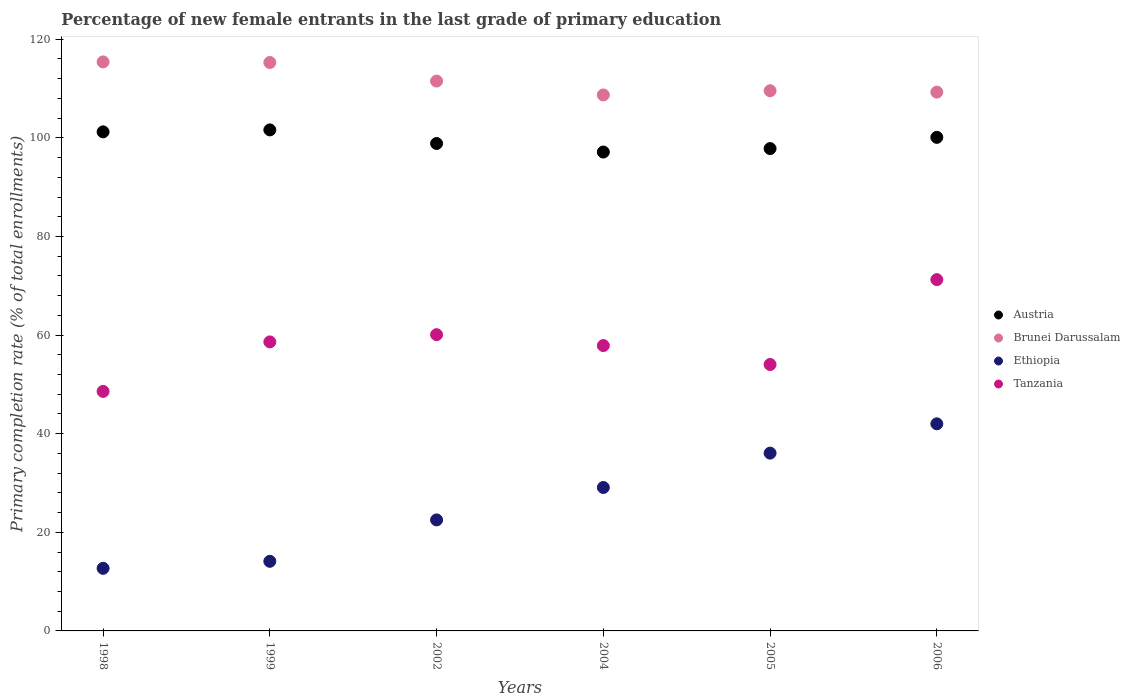Is the number of dotlines equal to the number of legend labels?
Give a very brief answer. Yes. What is the percentage of new female entrants in Ethiopia in 2005?
Offer a terse response. 36.06. Across all years, what is the maximum percentage of new female entrants in Ethiopia?
Ensure brevity in your answer.  42. Across all years, what is the minimum percentage of new female entrants in Austria?
Your response must be concise. 97.12. What is the total percentage of new female entrants in Ethiopia in the graph?
Your answer should be very brief. 156.48. What is the difference between the percentage of new female entrants in Ethiopia in 1998 and that in 2004?
Your answer should be very brief. -16.39. What is the difference between the percentage of new female entrants in Ethiopia in 2006 and the percentage of new female entrants in Brunei Darussalam in 2004?
Provide a succinct answer. -66.7. What is the average percentage of new female entrants in Austria per year?
Your answer should be compact. 99.45. In the year 1999, what is the difference between the percentage of new female entrants in Tanzania and percentage of new female entrants in Ethiopia?
Provide a succinct answer. 44.5. What is the ratio of the percentage of new female entrants in Ethiopia in 2002 to that in 2005?
Your answer should be compact. 0.62. Is the difference between the percentage of new female entrants in Tanzania in 2002 and 2004 greater than the difference between the percentage of new female entrants in Ethiopia in 2002 and 2004?
Offer a terse response. Yes. What is the difference between the highest and the second highest percentage of new female entrants in Brunei Darussalam?
Ensure brevity in your answer.  0.12. What is the difference between the highest and the lowest percentage of new female entrants in Brunei Darussalam?
Make the answer very short. 6.7. Is the sum of the percentage of new female entrants in Austria in 2002 and 2006 greater than the maximum percentage of new female entrants in Ethiopia across all years?
Provide a succinct answer. Yes. Is it the case that in every year, the sum of the percentage of new female entrants in Austria and percentage of new female entrants in Tanzania  is greater than the percentage of new female entrants in Brunei Darussalam?
Your answer should be compact. Yes. Does the percentage of new female entrants in Austria monotonically increase over the years?
Keep it short and to the point. No. Is the percentage of new female entrants in Austria strictly greater than the percentage of new female entrants in Brunei Darussalam over the years?
Your answer should be very brief. No. Is the percentage of new female entrants in Ethiopia strictly less than the percentage of new female entrants in Brunei Darussalam over the years?
Provide a short and direct response. Yes. What is the difference between two consecutive major ticks on the Y-axis?
Keep it short and to the point. 20. Are the values on the major ticks of Y-axis written in scientific E-notation?
Your answer should be very brief. No. Where does the legend appear in the graph?
Keep it short and to the point. Center right. What is the title of the graph?
Your response must be concise. Percentage of new female entrants in the last grade of primary education. What is the label or title of the X-axis?
Give a very brief answer. Years. What is the label or title of the Y-axis?
Offer a terse response. Primary completion rate (% of total enrollments). What is the Primary completion rate (% of total enrollments) in Austria in 1998?
Ensure brevity in your answer.  101.21. What is the Primary completion rate (% of total enrollments) in Brunei Darussalam in 1998?
Your answer should be very brief. 115.4. What is the Primary completion rate (% of total enrollments) in Ethiopia in 1998?
Offer a very short reply. 12.7. What is the Primary completion rate (% of total enrollments) in Tanzania in 1998?
Provide a short and direct response. 48.58. What is the Primary completion rate (% of total enrollments) in Austria in 1999?
Provide a short and direct response. 101.61. What is the Primary completion rate (% of total enrollments) of Brunei Darussalam in 1999?
Offer a terse response. 115.28. What is the Primary completion rate (% of total enrollments) in Ethiopia in 1999?
Your answer should be very brief. 14.12. What is the Primary completion rate (% of total enrollments) of Tanzania in 1999?
Make the answer very short. 58.62. What is the Primary completion rate (% of total enrollments) in Austria in 2002?
Give a very brief answer. 98.85. What is the Primary completion rate (% of total enrollments) of Brunei Darussalam in 2002?
Provide a short and direct response. 111.51. What is the Primary completion rate (% of total enrollments) of Ethiopia in 2002?
Offer a very short reply. 22.51. What is the Primary completion rate (% of total enrollments) of Tanzania in 2002?
Keep it short and to the point. 60.09. What is the Primary completion rate (% of total enrollments) in Austria in 2004?
Your response must be concise. 97.12. What is the Primary completion rate (% of total enrollments) of Brunei Darussalam in 2004?
Keep it short and to the point. 108.7. What is the Primary completion rate (% of total enrollments) in Ethiopia in 2004?
Offer a terse response. 29.09. What is the Primary completion rate (% of total enrollments) in Tanzania in 2004?
Your answer should be compact. 57.87. What is the Primary completion rate (% of total enrollments) of Austria in 2005?
Your answer should be very brief. 97.82. What is the Primary completion rate (% of total enrollments) of Brunei Darussalam in 2005?
Ensure brevity in your answer.  109.55. What is the Primary completion rate (% of total enrollments) in Ethiopia in 2005?
Offer a very short reply. 36.06. What is the Primary completion rate (% of total enrollments) in Tanzania in 2005?
Your answer should be very brief. 54.04. What is the Primary completion rate (% of total enrollments) in Austria in 2006?
Make the answer very short. 100.1. What is the Primary completion rate (% of total enrollments) of Brunei Darussalam in 2006?
Give a very brief answer. 109.27. What is the Primary completion rate (% of total enrollments) of Ethiopia in 2006?
Make the answer very short. 42. What is the Primary completion rate (% of total enrollments) in Tanzania in 2006?
Your answer should be compact. 71.25. Across all years, what is the maximum Primary completion rate (% of total enrollments) of Austria?
Keep it short and to the point. 101.61. Across all years, what is the maximum Primary completion rate (% of total enrollments) in Brunei Darussalam?
Provide a short and direct response. 115.4. Across all years, what is the maximum Primary completion rate (% of total enrollments) of Ethiopia?
Give a very brief answer. 42. Across all years, what is the maximum Primary completion rate (% of total enrollments) of Tanzania?
Your answer should be very brief. 71.25. Across all years, what is the minimum Primary completion rate (% of total enrollments) of Austria?
Make the answer very short. 97.12. Across all years, what is the minimum Primary completion rate (% of total enrollments) in Brunei Darussalam?
Provide a succinct answer. 108.7. Across all years, what is the minimum Primary completion rate (% of total enrollments) in Ethiopia?
Provide a succinct answer. 12.7. Across all years, what is the minimum Primary completion rate (% of total enrollments) in Tanzania?
Your answer should be very brief. 48.58. What is the total Primary completion rate (% of total enrollments) of Austria in the graph?
Give a very brief answer. 596.72. What is the total Primary completion rate (% of total enrollments) of Brunei Darussalam in the graph?
Offer a terse response. 669.72. What is the total Primary completion rate (% of total enrollments) in Ethiopia in the graph?
Offer a terse response. 156.48. What is the total Primary completion rate (% of total enrollments) in Tanzania in the graph?
Make the answer very short. 350.43. What is the difference between the Primary completion rate (% of total enrollments) of Austria in 1998 and that in 1999?
Your response must be concise. -0.4. What is the difference between the Primary completion rate (% of total enrollments) of Brunei Darussalam in 1998 and that in 1999?
Your answer should be compact. 0.12. What is the difference between the Primary completion rate (% of total enrollments) in Ethiopia in 1998 and that in 1999?
Provide a succinct answer. -1.42. What is the difference between the Primary completion rate (% of total enrollments) of Tanzania in 1998 and that in 1999?
Your answer should be compact. -10.04. What is the difference between the Primary completion rate (% of total enrollments) in Austria in 1998 and that in 2002?
Make the answer very short. 2.36. What is the difference between the Primary completion rate (% of total enrollments) of Brunei Darussalam in 1998 and that in 2002?
Give a very brief answer. 3.89. What is the difference between the Primary completion rate (% of total enrollments) of Ethiopia in 1998 and that in 2002?
Keep it short and to the point. -9.82. What is the difference between the Primary completion rate (% of total enrollments) of Tanzania in 1998 and that in 2002?
Make the answer very short. -11.51. What is the difference between the Primary completion rate (% of total enrollments) of Austria in 1998 and that in 2004?
Keep it short and to the point. 4.09. What is the difference between the Primary completion rate (% of total enrollments) in Brunei Darussalam in 1998 and that in 2004?
Your answer should be very brief. 6.7. What is the difference between the Primary completion rate (% of total enrollments) in Ethiopia in 1998 and that in 2004?
Offer a very short reply. -16.39. What is the difference between the Primary completion rate (% of total enrollments) of Tanzania in 1998 and that in 2004?
Your response must be concise. -9.29. What is the difference between the Primary completion rate (% of total enrollments) of Austria in 1998 and that in 2005?
Your answer should be compact. 3.39. What is the difference between the Primary completion rate (% of total enrollments) of Brunei Darussalam in 1998 and that in 2005?
Offer a terse response. 5.85. What is the difference between the Primary completion rate (% of total enrollments) of Ethiopia in 1998 and that in 2005?
Keep it short and to the point. -23.36. What is the difference between the Primary completion rate (% of total enrollments) of Tanzania in 1998 and that in 2005?
Keep it short and to the point. -5.46. What is the difference between the Primary completion rate (% of total enrollments) of Austria in 1998 and that in 2006?
Give a very brief answer. 1.11. What is the difference between the Primary completion rate (% of total enrollments) of Brunei Darussalam in 1998 and that in 2006?
Give a very brief answer. 6.13. What is the difference between the Primary completion rate (% of total enrollments) in Ethiopia in 1998 and that in 2006?
Keep it short and to the point. -29.3. What is the difference between the Primary completion rate (% of total enrollments) of Tanzania in 1998 and that in 2006?
Make the answer very short. -22.67. What is the difference between the Primary completion rate (% of total enrollments) in Austria in 1999 and that in 2002?
Ensure brevity in your answer.  2.76. What is the difference between the Primary completion rate (% of total enrollments) in Brunei Darussalam in 1999 and that in 2002?
Keep it short and to the point. 3.77. What is the difference between the Primary completion rate (% of total enrollments) of Ethiopia in 1999 and that in 2002?
Offer a very short reply. -8.4. What is the difference between the Primary completion rate (% of total enrollments) in Tanzania in 1999 and that in 2002?
Your answer should be very brief. -1.47. What is the difference between the Primary completion rate (% of total enrollments) of Austria in 1999 and that in 2004?
Ensure brevity in your answer.  4.49. What is the difference between the Primary completion rate (% of total enrollments) of Brunei Darussalam in 1999 and that in 2004?
Provide a short and direct response. 6.58. What is the difference between the Primary completion rate (% of total enrollments) in Ethiopia in 1999 and that in 2004?
Your response must be concise. -14.97. What is the difference between the Primary completion rate (% of total enrollments) in Tanzania in 1999 and that in 2004?
Keep it short and to the point. 0.75. What is the difference between the Primary completion rate (% of total enrollments) in Austria in 1999 and that in 2005?
Provide a succinct answer. 3.79. What is the difference between the Primary completion rate (% of total enrollments) of Brunei Darussalam in 1999 and that in 2005?
Keep it short and to the point. 5.73. What is the difference between the Primary completion rate (% of total enrollments) in Ethiopia in 1999 and that in 2005?
Offer a very short reply. -21.94. What is the difference between the Primary completion rate (% of total enrollments) in Tanzania in 1999 and that in 2005?
Your response must be concise. 4.58. What is the difference between the Primary completion rate (% of total enrollments) in Austria in 1999 and that in 2006?
Give a very brief answer. 1.51. What is the difference between the Primary completion rate (% of total enrollments) in Brunei Darussalam in 1999 and that in 2006?
Your answer should be very brief. 6.01. What is the difference between the Primary completion rate (% of total enrollments) of Ethiopia in 1999 and that in 2006?
Provide a succinct answer. -27.88. What is the difference between the Primary completion rate (% of total enrollments) in Tanzania in 1999 and that in 2006?
Provide a short and direct response. -12.63. What is the difference between the Primary completion rate (% of total enrollments) in Austria in 2002 and that in 2004?
Your answer should be very brief. 1.73. What is the difference between the Primary completion rate (% of total enrollments) of Brunei Darussalam in 2002 and that in 2004?
Your response must be concise. 2.81. What is the difference between the Primary completion rate (% of total enrollments) of Ethiopia in 2002 and that in 2004?
Your answer should be very brief. -6.58. What is the difference between the Primary completion rate (% of total enrollments) of Tanzania in 2002 and that in 2004?
Give a very brief answer. 2.22. What is the difference between the Primary completion rate (% of total enrollments) in Austria in 2002 and that in 2005?
Keep it short and to the point. 1.03. What is the difference between the Primary completion rate (% of total enrollments) in Brunei Darussalam in 2002 and that in 2005?
Your answer should be very brief. 1.96. What is the difference between the Primary completion rate (% of total enrollments) of Ethiopia in 2002 and that in 2005?
Your response must be concise. -13.54. What is the difference between the Primary completion rate (% of total enrollments) in Tanzania in 2002 and that in 2005?
Make the answer very short. 6.05. What is the difference between the Primary completion rate (% of total enrollments) in Austria in 2002 and that in 2006?
Offer a terse response. -1.25. What is the difference between the Primary completion rate (% of total enrollments) in Brunei Darussalam in 2002 and that in 2006?
Offer a very short reply. 2.24. What is the difference between the Primary completion rate (% of total enrollments) of Ethiopia in 2002 and that in 2006?
Your answer should be compact. -19.49. What is the difference between the Primary completion rate (% of total enrollments) in Tanzania in 2002 and that in 2006?
Your answer should be compact. -11.16. What is the difference between the Primary completion rate (% of total enrollments) in Austria in 2004 and that in 2005?
Your answer should be compact. -0.7. What is the difference between the Primary completion rate (% of total enrollments) in Brunei Darussalam in 2004 and that in 2005?
Provide a succinct answer. -0.85. What is the difference between the Primary completion rate (% of total enrollments) of Ethiopia in 2004 and that in 2005?
Give a very brief answer. -6.97. What is the difference between the Primary completion rate (% of total enrollments) of Tanzania in 2004 and that in 2005?
Provide a succinct answer. 3.83. What is the difference between the Primary completion rate (% of total enrollments) of Austria in 2004 and that in 2006?
Ensure brevity in your answer.  -2.98. What is the difference between the Primary completion rate (% of total enrollments) in Brunei Darussalam in 2004 and that in 2006?
Make the answer very short. -0.58. What is the difference between the Primary completion rate (% of total enrollments) of Ethiopia in 2004 and that in 2006?
Give a very brief answer. -12.91. What is the difference between the Primary completion rate (% of total enrollments) in Tanzania in 2004 and that in 2006?
Your response must be concise. -13.38. What is the difference between the Primary completion rate (% of total enrollments) in Austria in 2005 and that in 2006?
Your answer should be compact. -2.28. What is the difference between the Primary completion rate (% of total enrollments) in Brunei Darussalam in 2005 and that in 2006?
Give a very brief answer. 0.28. What is the difference between the Primary completion rate (% of total enrollments) of Ethiopia in 2005 and that in 2006?
Ensure brevity in your answer.  -5.94. What is the difference between the Primary completion rate (% of total enrollments) of Tanzania in 2005 and that in 2006?
Offer a very short reply. -17.21. What is the difference between the Primary completion rate (% of total enrollments) of Austria in 1998 and the Primary completion rate (% of total enrollments) of Brunei Darussalam in 1999?
Keep it short and to the point. -14.07. What is the difference between the Primary completion rate (% of total enrollments) in Austria in 1998 and the Primary completion rate (% of total enrollments) in Ethiopia in 1999?
Ensure brevity in your answer.  87.1. What is the difference between the Primary completion rate (% of total enrollments) in Austria in 1998 and the Primary completion rate (% of total enrollments) in Tanzania in 1999?
Your answer should be compact. 42.6. What is the difference between the Primary completion rate (% of total enrollments) of Brunei Darussalam in 1998 and the Primary completion rate (% of total enrollments) of Ethiopia in 1999?
Provide a short and direct response. 101.29. What is the difference between the Primary completion rate (% of total enrollments) of Brunei Darussalam in 1998 and the Primary completion rate (% of total enrollments) of Tanzania in 1999?
Your answer should be compact. 56.79. What is the difference between the Primary completion rate (% of total enrollments) in Ethiopia in 1998 and the Primary completion rate (% of total enrollments) in Tanzania in 1999?
Provide a succinct answer. -45.92. What is the difference between the Primary completion rate (% of total enrollments) of Austria in 1998 and the Primary completion rate (% of total enrollments) of Brunei Darussalam in 2002?
Offer a very short reply. -10.3. What is the difference between the Primary completion rate (% of total enrollments) of Austria in 1998 and the Primary completion rate (% of total enrollments) of Ethiopia in 2002?
Ensure brevity in your answer.  78.7. What is the difference between the Primary completion rate (% of total enrollments) of Austria in 1998 and the Primary completion rate (% of total enrollments) of Tanzania in 2002?
Give a very brief answer. 41.13. What is the difference between the Primary completion rate (% of total enrollments) in Brunei Darussalam in 1998 and the Primary completion rate (% of total enrollments) in Ethiopia in 2002?
Provide a short and direct response. 92.89. What is the difference between the Primary completion rate (% of total enrollments) of Brunei Darussalam in 1998 and the Primary completion rate (% of total enrollments) of Tanzania in 2002?
Offer a terse response. 55.32. What is the difference between the Primary completion rate (% of total enrollments) of Ethiopia in 1998 and the Primary completion rate (% of total enrollments) of Tanzania in 2002?
Make the answer very short. -47.39. What is the difference between the Primary completion rate (% of total enrollments) of Austria in 1998 and the Primary completion rate (% of total enrollments) of Brunei Darussalam in 2004?
Ensure brevity in your answer.  -7.48. What is the difference between the Primary completion rate (% of total enrollments) in Austria in 1998 and the Primary completion rate (% of total enrollments) in Ethiopia in 2004?
Your answer should be compact. 72.12. What is the difference between the Primary completion rate (% of total enrollments) in Austria in 1998 and the Primary completion rate (% of total enrollments) in Tanzania in 2004?
Provide a succinct answer. 43.35. What is the difference between the Primary completion rate (% of total enrollments) in Brunei Darussalam in 1998 and the Primary completion rate (% of total enrollments) in Ethiopia in 2004?
Your answer should be compact. 86.31. What is the difference between the Primary completion rate (% of total enrollments) of Brunei Darussalam in 1998 and the Primary completion rate (% of total enrollments) of Tanzania in 2004?
Offer a very short reply. 57.53. What is the difference between the Primary completion rate (% of total enrollments) of Ethiopia in 1998 and the Primary completion rate (% of total enrollments) of Tanzania in 2004?
Keep it short and to the point. -45.17. What is the difference between the Primary completion rate (% of total enrollments) in Austria in 1998 and the Primary completion rate (% of total enrollments) in Brunei Darussalam in 2005?
Give a very brief answer. -8.34. What is the difference between the Primary completion rate (% of total enrollments) in Austria in 1998 and the Primary completion rate (% of total enrollments) in Ethiopia in 2005?
Provide a short and direct response. 65.16. What is the difference between the Primary completion rate (% of total enrollments) in Austria in 1998 and the Primary completion rate (% of total enrollments) in Tanzania in 2005?
Provide a succinct answer. 47.18. What is the difference between the Primary completion rate (% of total enrollments) in Brunei Darussalam in 1998 and the Primary completion rate (% of total enrollments) in Ethiopia in 2005?
Your answer should be very brief. 79.34. What is the difference between the Primary completion rate (% of total enrollments) in Brunei Darussalam in 1998 and the Primary completion rate (% of total enrollments) in Tanzania in 2005?
Ensure brevity in your answer.  61.37. What is the difference between the Primary completion rate (% of total enrollments) of Ethiopia in 1998 and the Primary completion rate (% of total enrollments) of Tanzania in 2005?
Your answer should be compact. -41.34. What is the difference between the Primary completion rate (% of total enrollments) of Austria in 1998 and the Primary completion rate (% of total enrollments) of Brunei Darussalam in 2006?
Make the answer very short. -8.06. What is the difference between the Primary completion rate (% of total enrollments) of Austria in 1998 and the Primary completion rate (% of total enrollments) of Ethiopia in 2006?
Give a very brief answer. 59.21. What is the difference between the Primary completion rate (% of total enrollments) in Austria in 1998 and the Primary completion rate (% of total enrollments) in Tanzania in 2006?
Make the answer very short. 29.97. What is the difference between the Primary completion rate (% of total enrollments) of Brunei Darussalam in 1998 and the Primary completion rate (% of total enrollments) of Ethiopia in 2006?
Ensure brevity in your answer.  73.4. What is the difference between the Primary completion rate (% of total enrollments) of Brunei Darussalam in 1998 and the Primary completion rate (% of total enrollments) of Tanzania in 2006?
Provide a short and direct response. 44.16. What is the difference between the Primary completion rate (% of total enrollments) of Ethiopia in 1998 and the Primary completion rate (% of total enrollments) of Tanzania in 2006?
Your response must be concise. -58.55. What is the difference between the Primary completion rate (% of total enrollments) of Austria in 1999 and the Primary completion rate (% of total enrollments) of Brunei Darussalam in 2002?
Your answer should be very brief. -9.9. What is the difference between the Primary completion rate (% of total enrollments) in Austria in 1999 and the Primary completion rate (% of total enrollments) in Ethiopia in 2002?
Keep it short and to the point. 79.1. What is the difference between the Primary completion rate (% of total enrollments) in Austria in 1999 and the Primary completion rate (% of total enrollments) in Tanzania in 2002?
Make the answer very short. 41.53. What is the difference between the Primary completion rate (% of total enrollments) in Brunei Darussalam in 1999 and the Primary completion rate (% of total enrollments) in Ethiopia in 2002?
Provide a succinct answer. 92.77. What is the difference between the Primary completion rate (% of total enrollments) in Brunei Darussalam in 1999 and the Primary completion rate (% of total enrollments) in Tanzania in 2002?
Give a very brief answer. 55.2. What is the difference between the Primary completion rate (% of total enrollments) of Ethiopia in 1999 and the Primary completion rate (% of total enrollments) of Tanzania in 2002?
Your answer should be compact. -45.97. What is the difference between the Primary completion rate (% of total enrollments) in Austria in 1999 and the Primary completion rate (% of total enrollments) in Brunei Darussalam in 2004?
Make the answer very short. -7.09. What is the difference between the Primary completion rate (% of total enrollments) of Austria in 1999 and the Primary completion rate (% of total enrollments) of Ethiopia in 2004?
Make the answer very short. 72.52. What is the difference between the Primary completion rate (% of total enrollments) of Austria in 1999 and the Primary completion rate (% of total enrollments) of Tanzania in 2004?
Provide a short and direct response. 43.74. What is the difference between the Primary completion rate (% of total enrollments) of Brunei Darussalam in 1999 and the Primary completion rate (% of total enrollments) of Ethiopia in 2004?
Ensure brevity in your answer.  86.19. What is the difference between the Primary completion rate (% of total enrollments) in Brunei Darussalam in 1999 and the Primary completion rate (% of total enrollments) in Tanzania in 2004?
Your response must be concise. 57.41. What is the difference between the Primary completion rate (% of total enrollments) in Ethiopia in 1999 and the Primary completion rate (% of total enrollments) in Tanzania in 2004?
Offer a terse response. -43.75. What is the difference between the Primary completion rate (% of total enrollments) in Austria in 1999 and the Primary completion rate (% of total enrollments) in Brunei Darussalam in 2005?
Give a very brief answer. -7.94. What is the difference between the Primary completion rate (% of total enrollments) in Austria in 1999 and the Primary completion rate (% of total enrollments) in Ethiopia in 2005?
Your answer should be very brief. 65.55. What is the difference between the Primary completion rate (% of total enrollments) of Austria in 1999 and the Primary completion rate (% of total enrollments) of Tanzania in 2005?
Provide a succinct answer. 47.57. What is the difference between the Primary completion rate (% of total enrollments) in Brunei Darussalam in 1999 and the Primary completion rate (% of total enrollments) in Ethiopia in 2005?
Your answer should be very brief. 79.22. What is the difference between the Primary completion rate (% of total enrollments) of Brunei Darussalam in 1999 and the Primary completion rate (% of total enrollments) of Tanzania in 2005?
Provide a short and direct response. 61.24. What is the difference between the Primary completion rate (% of total enrollments) of Ethiopia in 1999 and the Primary completion rate (% of total enrollments) of Tanzania in 2005?
Give a very brief answer. -39.92. What is the difference between the Primary completion rate (% of total enrollments) of Austria in 1999 and the Primary completion rate (% of total enrollments) of Brunei Darussalam in 2006?
Provide a succinct answer. -7.66. What is the difference between the Primary completion rate (% of total enrollments) of Austria in 1999 and the Primary completion rate (% of total enrollments) of Ethiopia in 2006?
Give a very brief answer. 59.61. What is the difference between the Primary completion rate (% of total enrollments) in Austria in 1999 and the Primary completion rate (% of total enrollments) in Tanzania in 2006?
Your answer should be very brief. 30.37. What is the difference between the Primary completion rate (% of total enrollments) of Brunei Darussalam in 1999 and the Primary completion rate (% of total enrollments) of Ethiopia in 2006?
Your answer should be very brief. 73.28. What is the difference between the Primary completion rate (% of total enrollments) of Brunei Darussalam in 1999 and the Primary completion rate (% of total enrollments) of Tanzania in 2006?
Offer a very short reply. 44.03. What is the difference between the Primary completion rate (% of total enrollments) of Ethiopia in 1999 and the Primary completion rate (% of total enrollments) of Tanzania in 2006?
Your answer should be compact. -57.13. What is the difference between the Primary completion rate (% of total enrollments) of Austria in 2002 and the Primary completion rate (% of total enrollments) of Brunei Darussalam in 2004?
Keep it short and to the point. -9.84. What is the difference between the Primary completion rate (% of total enrollments) in Austria in 2002 and the Primary completion rate (% of total enrollments) in Ethiopia in 2004?
Ensure brevity in your answer.  69.76. What is the difference between the Primary completion rate (% of total enrollments) in Austria in 2002 and the Primary completion rate (% of total enrollments) in Tanzania in 2004?
Offer a very short reply. 40.99. What is the difference between the Primary completion rate (% of total enrollments) in Brunei Darussalam in 2002 and the Primary completion rate (% of total enrollments) in Ethiopia in 2004?
Your answer should be very brief. 82.42. What is the difference between the Primary completion rate (% of total enrollments) of Brunei Darussalam in 2002 and the Primary completion rate (% of total enrollments) of Tanzania in 2004?
Provide a succinct answer. 53.65. What is the difference between the Primary completion rate (% of total enrollments) in Ethiopia in 2002 and the Primary completion rate (% of total enrollments) in Tanzania in 2004?
Provide a succinct answer. -35.35. What is the difference between the Primary completion rate (% of total enrollments) of Austria in 2002 and the Primary completion rate (% of total enrollments) of Brunei Darussalam in 2005?
Provide a short and direct response. -10.7. What is the difference between the Primary completion rate (% of total enrollments) in Austria in 2002 and the Primary completion rate (% of total enrollments) in Ethiopia in 2005?
Make the answer very short. 62.8. What is the difference between the Primary completion rate (% of total enrollments) of Austria in 2002 and the Primary completion rate (% of total enrollments) of Tanzania in 2005?
Offer a terse response. 44.82. What is the difference between the Primary completion rate (% of total enrollments) of Brunei Darussalam in 2002 and the Primary completion rate (% of total enrollments) of Ethiopia in 2005?
Ensure brevity in your answer.  75.45. What is the difference between the Primary completion rate (% of total enrollments) in Brunei Darussalam in 2002 and the Primary completion rate (% of total enrollments) in Tanzania in 2005?
Provide a short and direct response. 57.48. What is the difference between the Primary completion rate (% of total enrollments) in Ethiopia in 2002 and the Primary completion rate (% of total enrollments) in Tanzania in 2005?
Your answer should be compact. -31.52. What is the difference between the Primary completion rate (% of total enrollments) of Austria in 2002 and the Primary completion rate (% of total enrollments) of Brunei Darussalam in 2006?
Give a very brief answer. -10.42. What is the difference between the Primary completion rate (% of total enrollments) of Austria in 2002 and the Primary completion rate (% of total enrollments) of Ethiopia in 2006?
Your answer should be compact. 56.85. What is the difference between the Primary completion rate (% of total enrollments) in Austria in 2002 and the Primary completion rate (% of total enrollments) in Tanzania in 2006?
Provide a succinct answer. 27.61. What is the difference between the Primary completion rate (% of total enrollments) of Brunei Darussalam in 2002 and the Primary completion rate (% of total enrollments) of Ethiopia in 2006?
Offer a terse response. 69.51. What is the difference between the Primary completion rate (% of total enrollments) in Brunei Darussalam in 2002 and the Primary completion rate (% of total enrollments) in Tanzania in 2006?
Offer a terse response. 40.27. What is the difference between the Primary completion rate (% of total enrollments) of Ethiopia in 2002 and the Primary completion rate (% of total enrollments) of Tanzania in 2006?
Your answer should be very brief. -48.73. What is the difference between the Primary completion rate (% of total enrollments) of Austria in 2004 and the Primary completion rate (% of total enrollments) of Brunei Darussalam in 2005?
Give a very brief answer. -12.43. What is the difference between the Primary completion rate (% of total enrollments) in Austria in 2004 and the Primary completion rate (% of total enrollments) in Ethiopia in 2005?
Ensure brevity in your answer.  61.06. What is the difference between the Primary completion rate (% of total enrollments) of Austria in 2004 and the Primary completion rate (% of total enrollments) of Tanzania in 2005?
Give a very brief answer. 43.08. What is the difference between the Primary completion rate (% of total enrollments) in Brunei Darussalam in 2004 and the Primary completion rate (% of total enrollments) in Ethiopia in 2005?
Offer a very short reply. 72.64. What is the difference between the Primary completion rate (% of total enrollments) in Brunei Darussalam in 2004 and the Primary completion rate (% of total enrollments) in Tanzania in 2005?
Keep it short and to the point. 54.66. What is the difference between the Primary completion rate (% of total enrollments) in Ethiopia in 2004 and the Primary completion rate (% of total enrollments) in Tanzania in 2005?
Your answer should be very brief. -24.95. What is the difference between the Primary completion rate (% of total enrollments) in Austria in 2004 and the Primary completion rate (% of total enrollments) in Brunei Darussalam in 2006?
Your response must be concise. -12.15. What is the difference between the Primary completion rate (% of total enrollments) in Austria in 2004 and the Primary completion rate (% of total enrollments) in Ethiopia in 2006?
Ensure brevity in your answer.  55.12. What is the difference between the Primary completion rate (% of total enrollments) of Austria in 2004 and the Primary completion rate (% of total enrollments) of Tanzania in 2006?
Your response must be concise. 25.88. What is the difference between the Primary completion rate (% of total enrollments) in Brunei Darussalam in 2004 and the Primary completion rate (% of total enrollments) in Ethiopia in 2006?
Provide a succinct answer. 66.7. What is the difference between the Primary completion rate (% of total enrollments) in Brunei Darussalam in 2004 and the Primary completion rate (% of total enrollments) in Tanzania in 2006?
Provide a succinct answer. 37.45. What is the difference between the Primary completion rate (% of total enrollments) of Ethiopia in 2004 and the Primary completion rate (% of total enrollments) of Tanzania in 2006?
Offer a terse response. -42.16. What is the difference between the Primary completion rate (% of total enrollments) of Austria in 2005 and the Primary completion rate (% of total enrollments) of Brunei Darussalam in 2006?
Your answer should be very brief. -11.45. What is the difference between the Primary completion rate (% of total enrollments) of Austria in 2005 and the Primary completion rate (% of total enrollments) of Ethiopia in 2006?
Keep it short and to the point. 55.82. What is the difference between the Primary completion rate (% of total enrollments) in Austria in 2005 and the Primary completion rate (% of total enrollments) in Tanzania in 2006?
Keep it short and to the point. 26.57. What is the difference between the Primary completion rate (% of total enrollments) of Brunei Darussalam in 2005 and the Primary completion rate (% of total enrollments) of Ethiopia in 2006?
Your response must be concise. 67.55. What is the difference between the Primary completion rate (% of total enrollments) in Brunei Darussalam in 2005 and the Primary completion rate (% of total enrollments) in Tanzania in 2006?
Make the answer very short. 38.31. What is the difference between the Primary completion rate (% of total enrollments) in Ethiopia in 2005 and the Primary completion rate (% of total enrollments) in Tanzania in 2006?
Offer a terse response. -35.19. What is the average Primary completion rate (% of total enrollments) in Austria per year?
Ensure brevity in your answer.  99.45. What is the average Primary completion rate (% of total enrollments) in Brunei Darussalam per year?
Offer a terse response. 111.62. What is the average Primary completion rate (% of total enrollments) of Ethiopia per year?
Keep it short and to the point. 26.08. What is the average Primary completion rate (% of total enrollments) in Tanzania per year?
Offer a terse response. 58.4. In the year 1998, what is the difference between the Primary completion rate (% of total enrollments) in Austria and Primary completion rate (% of total enrollments) in Brunei Darussalam?
Your answer should be compact. -14.19. In the year 1998, what is the difference between the Primary completion rate (% of total enrollments) in Austria and Primary completion rate (% of total enrollments) in Ethiopia?
Ensure brevity in your answer.  88.52. In the year 1998, what is the difference between the Primary completion rate (% of total enrollments) of Austria and Primary completion rate (% of total enrollments) of Tanzania?
Your answer should be very brief. 52.64. In the year 1998, what is the difference between the Primary completion rate (% of total enrollments) of Brunei Darussalam and Primary completion rate (% of total enrollments) of Ethiopia?
Offer a terse response. 102.71. In the year 1998, what is the difference between the Primary completion rate (% of total enrollments) in Brunei Darussalam and Primary completion rate (% of total enrollments) in Tanzania?
Your response must be concise. 66.83. In the year 1998, what is the difference between the Primary completion rate (% of total enrollments) of Ethiopia and Primary completion rate (% of total enrollments) of Tanzania?
Give a very brief answer. -35.88. In the year 1999, what is the difference between the Primary completion rate (% of total enrollments) in Austria and Primary completion rate (% of total enrollments) in Brunei Darussalam?
Your answer should be very brief. -13.67. In the year 1999, what is the difference between the Primary completion rate (% of total enrollments) in Austria and Primary completion rate (% of total enrollments) in Ethiopia?
Your answer should be compact. 87.49. In the year 1999, what is the difference between the Primary completion rate (% of total enrollments) in Austria and Primary completion rate (% of total enrollments) in Tanzania?
Give a very brief answer. 43. In the year 1999, what is the difference between the Primary completion rate (% of total enrollments) in Brunei Darussalam and Primary completion rate (% of total enrollments) in Ethiopia?
Offer a very short reply. 101.16. In the year 1999, what is the difference between the Primary completion rate (% of total enrollments) of Brunei Darussalam and Primary completion rate (% of total enrollments) of Tanzania?
Provide a short and direct response. 56.66. In the year 1999, what is the difference between the Primary completion rate (% of total enrollments) in Ethiopia and Primary completion rate (% of total enrollments) in Tanzania?
Ensure brevity in your answer.  -44.5. In the year 2002, what is the difference between the Primary completion rate (% of total enrollments) of Austria and Primary completion rate (% of total enrollments) of Brunei Darussalam?
Offer a very short reply. -12.66. In the year 2002, what is the difference between the Primary completion rate (% of total enrollments) in Austria and Primary completion rate (% of total enrollments) in Ethiopia?
Offer a very short reply. 76.34. In the year 2002, what is the difference between the Primary completion rate (% of total enrollments) in Austria and Primary completion rate (% of total enrollments) in Tanzania?
Keep it short and to the point. 38.77. In the year 2002, what is the difference between the Primary completion rate (% of total enrollments) of Brunei Darussalam and Primary completion rate (% of total enrollments) of Ethiopia?
Your answer should be compact. 89. In the year 2002, what is the difference between the Primary completion rate (% of total enrollments) in Brunei Darussalam and Primary completion rate (% of total enrollments) in Tanzania?
Offer a very short reply. 51.43. In the year 2002, what is the difference between the Primary completion rate (% of total enrollments) of Ethiopia and Primary completion rate (% of total enrollments) of Tanzania?
Provide a short and direct response. -37.57. In the year 2004, what is the difference between the Primary completion rate (% of total enrollments) in Austria and Primary completion rate (% of total enrollments) in Brunei Darussalam?
Make the answer very short. -11.58. In the year 2004, what is the difference between the Primary completion rate (% of total enrollments) of Austria and Primary completion rate (% of total enrollments) of Ethiopia?
Ensure brevity in your answer.  68.03. In the year 2004, what is the difference between the Primary completion rate (% of total enrollments) in Austria and Primary completion rate (% of total enrollments) in Tanzania?
Offer a very short reply. 39.25. In the year 2004, what is the difference between the Primary completion rate (% of total enrollments) in Brunei Darussalam and Primary completion rate (% of total enrollments) in Ethiopia?
Give a very brief answer. 79.61. In the year 2004, what is the difference between the Primary completion rate (% of total enrollments) of Brunei Darussalam and Primary completion rate (% of total enrollments) of Tanzania?
Your answer should be very brief. 50.83. In the year 2004, what is the difference between the Primary completion rate (% of total enrollments) of Ethiopia and Primary completion rate (% of total enrollments) of Tanzania?
Keep it short and to the point. -28.78. In the year 2005, what is the difference between the Primary completion rate (% of total enrollments) in Austria and Primary completion rate (% of total enrollments) in Brunei Darussalam?
Ensure brevity in your answer.  -11.73. In the year 2005, what is the difference between the Primary completion rate (% of total enrollments) of Austria and Primary completion rate (% of total enrollments) of Ethiopia?
Offer a terse response. 61.76. In the year 2005, what is the difference between the Primary completion rate (% of total enrollments) in Austria and Primary completion rate (% of total enrollments) in Tanzania?
Keep it short and to the point. 43.78. In the year 2005, what is the difference between the Primary completion rate (% of total enrollments) of Brunei Darussalam and Primary completion rate (% of total enrollments) of Ethiopia?
Provide a succinct answer. 73.49. In the year 2005, what is the difference between the Primary completion rate (% of total enrollments) in Brunei Darussalam and Primary completion rate (% of total enrollments) in Tanzania?
Keep it short and to the point. 55.52. In the year 2005, what is the difference between the Primary completion rate (% of total enrollments) in Ethiopia and Primary completion rate (% of total enrollments) in Tanzania?
Your answer should be very brief. -17.98. In the year 2006, what is the difference between the Primary completion rate (% of total enrollments) of Austria and Primary completion rate (% of total enrollments) of Brunei Darussalam?
Make the answer very short. -9.17. In the year 2006, what is the difference between the Primary completion rate (% of total enrollments) of Austria and Primary completion rate (% of total enrollments) of Ethiopia?
Offer a terse response. 58.1. In the year 2006, what is the difference between the Primary completion rate (% of total enrollments) of Austria and Primary completion rate (% of total enrollments) of Tanzania?
Ensure brevity in your answer.  28.85. In the year 2006, what is the difference between the Primary completion rate (% of total enrollments) in Brunei Darussalam and Primary completion rate (% of total enrollments) in Ethiopia?
Offer a terse response. 67.27. In the year 2006, what is the difference between the Primary completion rate (% of total enrollments) in Brunei Darussalam and Primary completion rate (% of total enrollments) in Tanzania?
Make the answer very short. 38.03. In the year 2006, what is the difference between the Primary completion rate (% of total enrollments) in Ethiopia and Primary completion rate (% of total enrollments) in Tanzania?
Provide a short and direct response. -29.25. What is the ratio of the Primary completion rate (% of total enrollments) of Austria in 1998 to that in 1999?
Make the answer very short. 1. What is the ratio of the Primary completion rate (% of total enrollments) of Ethiopia in 1998 to that in 1999?
Make the answer very short. 0.9. What is the ratio of the Primary completion rate (% of total enrollments) of Tanzania in 1998 to that in 1999?
Your response must be concise. 0.83. What is the ratio of the Primary completion rate (% of total enrollments) in Austria in 1998 to that in 2002?
Offer a terse response. 1.02. What is the ratio of the Primary completion rate (% of total enrollments) in Brunei Darussalam in 1998 to that in 2002?
Your answer should be very brief. 1.03. What is the ratio of the Primary completion rate (% of total enrollments) of Ethiopia in 1998 to that in 2002?
Your response must be concise. 0.56. What is the ratio of the Primary completion rate (% of total enrollments) of Tanzania in 1998 to that in 2002?
Your answer should be very brief. 0.81. What is the ratio of the Primary completion rate (% of total enrollments) of Austria in 1998 to that in 2004?
Your answer should be compact. 1.04. What is the ratio of the Primary completion rate (% of total enrollments) of Brunei Darussalam in 1998 to that in 2004?
Your answer should be very brief. 1.06. What is the ratio of the Primary completion rate (% of total enrollments) of Ethiopia in 1998 to that in 2004?
Give a very brief answer. 0.44. What is the ratio of the Primary completion rate (% of total enrollments) in Tanzania in 1998 to that in 2004?
Offer a very short reply. 0.84. What is the ratio of the Primary completion rate (% of total enrollments) of Austria in 1998 to that in 2005?
Keep it short and to the point. 1.03. What is the ratio of the Primary completion rate (% of total enrollments) of Brunei Darussalam in 1998 to that in 2005?
Ensure brevity in your answer.  1.05. What is the ratio of the Primary completion rate (% of total enrollments) in Ethiopia in 1998 to that in 2005?
Keep it short and to the point. 0.35. What is the ratio of the Primary completion rate (% of total enrollments) in Tanzania in 1998 to that in 2005?
Your answer should be compact. 0.9. What is the ratio of the Primary completion rate (% of total enrollments) of Austria in 1998 to that in 2006?
Offer a terse response. 1.01. What is the ratio of the Primary completion rate (% of total enrollments) of Brunei Darussalam in 1998 to that in 2006?
Ensure brevity in your answer.  1.06. What is the ratio of the Primary completion rate (% of total enrollments) in Ethiopia in 1998 to that in 2006?
Your response must be concise. 0.3. What is the ratio of the Primary completion rate (% of total enrollments) in Tanzania in 1998 to that in 2006?
Ensure brevity in your answer.  0.68. What is the ratio of the Primary completion rate (% of total enrollments) in Austria in 1999 to that in 2002?
Offer a very short reply. 1.03. What is the ratio of the Primary completion rate (% of total enrollments) of Brunei Darussalam in 1999 to that in 2002?
Provide a short and direct response. 1.03. What is the ratio of the Primary completion rate (% of total enrollments) in Ethiopia in 1999 to that in 2002?
Provide a succinct answer. 0.63. What is the ratio of the Primary completion rate (% of total enrollments) in Tanzania in 1999 to that in 2002?
Provide a succinct answer. 0.98. What is the ratio of the Primary completion rate (% of total enrollments) of Austria in 1999 to that in 2004?
Keep it short and to the point. 1.05. What is the ratio of the Primary completion rate (% of total enrollments) in Brunei Darussalam in 1999 to that in 2004?
Your answer should be very brief. 1.06. What is the ratio of the Primary completion rate (% of total enrollments) of Ethiopia in 1999 to that in 2004?
Your answer should be very brief. 0.49. What is the ratio of the Primary completion rate (% of total enrollments) of Tanzania in 1999 to that in 2004?
Your answer should be compact. 1.01. What is the ratio of the Primary completion rate (% of total enrollments) in Austria in 1999 to that in 2005?
Ensure brevity in your answer.  1.04. What is the ratio of the Primary completion rate (% of total enrollments) of Brunei Darussalam in 1999 to that in 2005?
Give a very brief answer. 1.05. What is the ratio of the Primary completion rate (% of total enrollments) of Ethiopia in 1999 to that in 2005?
Provide a succinct answer. 0.39. What is the ratio of the Primary completion rate (% of total enrollments) of Tanzania in 1999 to that in 2005?
Offer a terse response. 1.08. What is the ratio of the Primary completion rate (% of total enrollments) in Austria in 1999 to that in 2006?
Provide a short and direct response. 1.02. What is the ratio of the Primary completion rate (% of total enrollments) of Brunei Darussalam in 1999 to that in 2006?
Ensure brevity in your answer.  1.05. What is the ratio of the Primary completion rate (% of total enrollments) in Ethiopia in 1999 to that in 2006?
Your answer should be compact. 0.34. What is the ratio of the Primary completion rate (% of total enrollments) in Tanzania in 1999 to that in 2006?
Make the answer very short. 0.82. What is the ratio of the Primary completion rate (% of total enrollments) in Austria in 2002 to that in 2004?
Ensure brevity in your answer.  1.02. What is the ratio of the Primary completion rate (% of total enrollments) of Brunei Darussalam in 2002 to that in 2004?
Give a very brief answer. 1.03. What is the ratio of the Primary completion rate (% of total enrollments) in Ethiopia in 2002 to that in 2004?
Your response must be concise. 0.77. What is the ratio of the Primary completion rate (% of total enrollments) of Tanzania in 2002 to that in 2004?
Give a very brief answer. 1.04. What is the ratio of the Primary completion rate (% of total enrollments) in Austria in 2002 to that in 2005?
Provide a succinct answer. 1.01. What is the ratio of the Primary completion rate (% of total enrollments) of Brunei Darussalam in 2002 to that in 2005?
Keep it short and to the point. 1.02. What is the ratio of the Primary completion rate (% of total enrollments) in Ethiopia in 2002 to that in 2005?
Ensure brevity in your answer.  0.62. What is the ratio of the Primary completion rate (% of total enrollments) in Tanzania in 2002 to that in 2005?
Your answer should be compact. 1.11. What is the ratio of the Primary completion rate (% of total enrollments) in Austria in 2002 to that in 2006?
Your response must be concise. 0.99. What is the ratio of the Primary completion rate (% of total enrollments) in Brunei Darussalam in 2002 to that in 2006?
Provide a short and direct response. 1.02. What is the ratio of the Primary completion rate (% of total enrollments) of Ethiopia in 2002 to that in 2006?
Give a very brief answer. 0.54. What is the ratio of the Primary completion rate (% of total enrollments) of Tanzania in 2002 to that in 2006?
Offer a very short reply. 0.84. What is the ratio of the Primary completion rate (% of total enrollments) of Ethiopia in 2004 to that in 2005?
Ensure brevity in your answer.  0.81. What is the ratio of the Primary completion rate (% of total enrollments) of Tanzania in 2004 to that in 2005?
Your answer should be very brief. 1.07. What is the ratio of the Primary completion rate (% of total enrollments) of Austria in 2004 to that in 2006?
Offer a very short reply. 0.97. What is the ratio of the Primary completion rate (% of total enrollments) of Ethiopia in 2004 to that in 2006?
Your answer should be very brief. 0.69. What is the ratio of the Primary completion rate (% of total enrollments) in Tanzania in 2004 to that in 2006?
Your answer should be compact. 0.81. What is the ratio of the Primary completion rate (% of total enrollments) of Austria in 2005 to that in 2006?
Ensure brevity in your answer.  0.98. What is the ratio of the Primary completion rate (% of total enrollments) of Ethiopia in 2005 to that in 2006?
Provide a short and direct response. 0.86. What is the ratio of the Primary completion rate (% of total enrollments) in Tanzania in 2005 to that in 2006?
Make the answer very short. 0.76. What is the difference between the highest and the second highest Primary completion rate (% of total enrollments) in Austria?
Your response must be concise. 0.4. What is the difference between the highest and the second highest Primary completion rate (% of total enrollments) of Brunei Darussalam?
Provide a short and direct response. 0.12. What is the difference between the highest and the second highest Primary completion rate (% of total enrollments) of Ethiopia?
Provide a succinct answer. 5.94. What is the difference between the highest and the second highest Primary completion rate (% of total enrollments) in Tanzania?
Offer a very short reply. 11.16. What is the difference between the highest and the lowest Primary completion rate (% of total enrollments) of Austria?
Ensure brevity in your answer.  4.49. What is the difference between the highest and the lowest Primary completion rate (% of total enrollments) of Brunei Darussalam?
Offer a terse response. 6.7. What is the difference between the highest and the lowest Primary completion rate (% of total enrollments) in Ethiopia?
Your answer should be very brief. 29.3. What is the difference between the highest and the lowest Primary completion rate (% of total enrollments) of Tanzania?
Give a very brief answer. 22.67. 